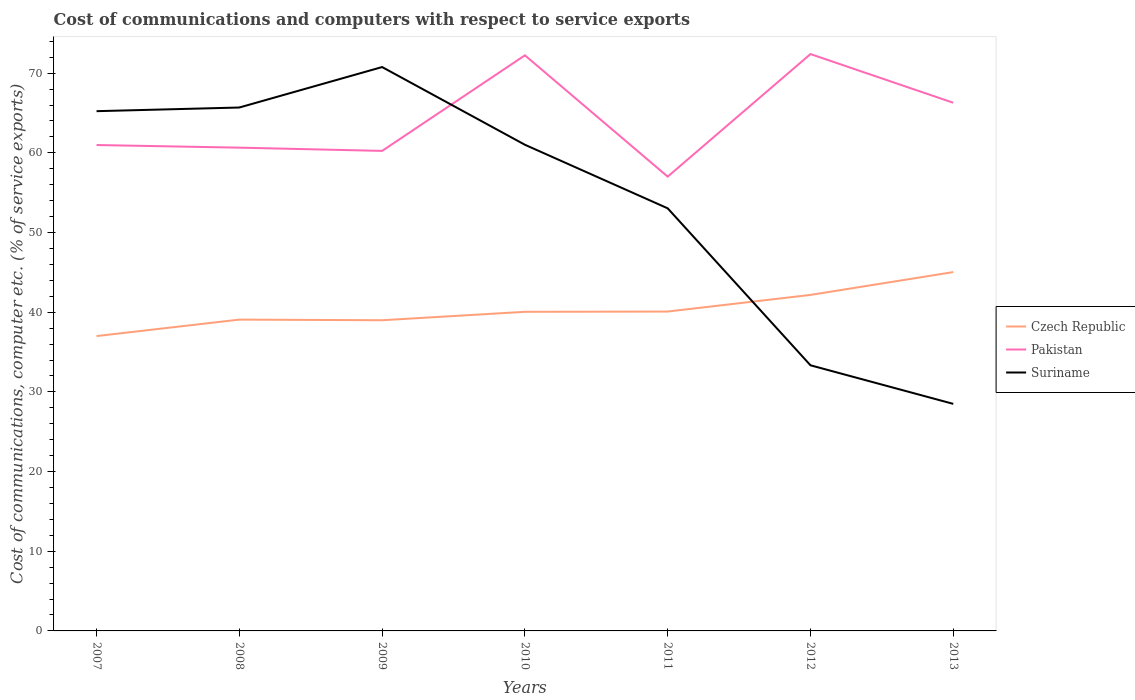Is the number of lines equal to the number of legend labels?
Keep it short and to the point. Yes. Across all years, what is the maximum cost of communications and computers in Czech Republic?
Keep it short and to the point. 37.01. In which year was the cost of communications and computers in Suriname maximum?
Ensure brevity in your answer.  2013. What is the total cost of communications and computers in Suriname in the graph?
Offer a very short reply. 24.54. What is the difference between the highest and the second highest cost of communications and computers in Pakistan?
Offer a very short reply. 15.38. What is the difference between the highest and the lowest cost of communications and computers in Czech Republic?
Ensure brevity in your answer.  2. How many lines are there?
Provide a succinct answer. 3. How many years are there in the graph?
Offer a terse response. 7. What is the difference between two consecutive major ticks on the Y-axis?
Make the answer very short. 10. Are the values on the major ticks of Y-axis written in scientific E-notation?
Offer a terse response. No. How are the legend labels stacked?
Your answer should be very brief. Vertical. What is the title of the graph?
Keep it short and to the point. Cost of communications and computers with respect to service exports. What is the label or title of the X-axis?
Your response must be concise. Years. What is the label or title of the Y-axis?
Ensure brevity in your answer.  Cost of communications, computer etc. (% of service exports). What is the Cost of communications, computer etc. (% of service exports) of Czech Republic in 2007?
Your answer should be compact. 37.01. What is the Cost of communications, computer etc. (% of service exports) in Pakistan in 2007?
Give a very brief answer. 60.98. What is the Cost of communications, computer etc. (% of service exports) in Suriname in 2007?
Provide a short and direct response. 65.23. What is the Cost of communications, computer etc. (% of service exports) of Czech Republic in 2008?
Make the answer very short. 39.07. What is the Cost of communications, computer etc. (% of service exports) of Pakistan in 2008?
Your answer should be very brief. 60.65. What is the Cost of communications, computer etc. (% of service exports) of Suriname in 2008?
Offer a very short reply. 65.69. What is the Cost of communications, computer etc. (% of service exports) in Czech Republic in 2009?
Provide a succinct answer. 38.99. What is the Cost of communications, computer etc. (% of service exports) in Pakistan in 2009?
Offer a very short reply. 60.25. What is the Cost of communications, computer etc. (% of service exports) in Suriname in 2009?
Ensure brevity in your answer.  70.77. What is the Cost of communications, computer etc. (% of service exports) of Czech Republic in 2010?
Keep it short and to the point. 40.05. What is the Cost of communications, computer etc. (% of service exports) of Pakistan in 2010?
Provide a short and direct response. 72.24. What is the Cost of communications, computer etc. (% of service exports) of Suriname in 2010?
Offer a very short reply. 61.02. What is the Cost of communications, computer etc. (% of service exports) in Czech Republic in 2011?
Ensure brevity in your answer.  40.09. What is the Cost of communications, computer etc. (% of service exports) of Pakistan in 2011?
Ensure brevity in your answer.  57.02. What is the Cost of communications, computer etc. (% of service exports) of Suriname in 2011?
Give a very brief answer. 53.04. What is the Cost of communications, computer etc. (% of service exports) in Czech Republic in 2012?
Provide a short and direct response. 42.17. What is the Cost of communications, computer etc. (% of service exports) in Pakistan in 2012?
Give a very brief answer. 72.4. What is the Cost of communications, computer etc. (% of service exports) in Suriname in 2012?
Make the answer very short. 33.34. What is the Cost of communications, computer etc. (% of service exports) of Czech Republic in 2013?
Provide a succinct answer. 45.04. What is the Cost of communications, computer etc. (% of service exports) of Pakistan in 2013?
Make the answer very short. 66.29. What is the Cost of communications, computer etc. (% of service exports) of Suriname in 2013?
Your answer should be very brief. 28.5. Across all years, what is the maximum Cost of communications, computer etc. (% of service exports) of Czech Republic?
Ensure brevity in your answer.  45.04. Across all years, what is the maximum Cost of communications, computer etc. (% of service exports) in Pakistan?
Offer a terse response. 72.4. Across all years, what is the maximum Cost of communications, computer etc. (% of service exports) in Suriname?
Ensure brevity in your answer.  70.77. Across all years, what is the minimum Cost of communications, computer etc. (% of service exports) in Czech Republic?
Your response must be concise. 37.01. Across all years, what is the minimum Cost of communications, computer etc. (% of service exports) in Pakistan?
Keep it short and to the point. 57.02. Across all years, what is the minimum Cost of communications, computer etc. (% of service exports) of Suriname?
Your answer should be compact. 28.5. What is the total Cost of communications, computer etc. (% of service exports) in Czech Republic in the graph?
Your answer should be compact. 282.42. What is the total Cost of communications, computer etc. (% of service exports) in Pakistan in the graph?
Give a very brief answer. 449.84. What is the total Cost of communications, computer etc. (% of service exports) of Suriname in the graph?
Your answer should be compact. 377.59. What is the difference between the Cost of communications, computer etc. (% of service exports) of Czech Republic in 2007 and that in 2008?
Your response must be concise. -2.07. What is the difference between the Cost of communications, computer etc. (% of service exports) in Pakistan in 2007 and that in 2008?
Keep it short and to the point. 0.33. What is the difference between the Cost of communications, computer etc. (% of service exports) in Suriname in 2007 and that in 2008?
Provide a short and direct response. -0.46. What is the difference between the Cost of communications, computer etc. (% of service exports) of Czech Republic in 2007 and that in 2009?
Provide a succinct answer. -1.99. What is the difference between the Cost of communications, computer etc. (% of service exports) of Pakistan in 2007 and that in 2009?
Keep it short and to the point. 0.74. What is the difference between the Cost of communications, computer etc. (% of service exports) of Suriname in 2007 and that in 2009?
Provide a short and direct response. -5.54. What is the difference between the Cost of communications, computer etc. (% of service exports) in Czech Republic in 2007 and that in 2010?
Ensure brevity in your answer.  -3.04. What is the difference between the Cost of communications, computer etc. (% of service exports) of Pakistan in 2007 and that in 2010?
Give a very brief answer. -11.26. What is the difference between the Cost of communications, computer etc. (% of service exports) of Suriname in 2007 and that in 2010?
Your answer should be compact. 4.21. What is the difference between the Cost of communications, computer etc. (% of service exports) in Czech Republic in 2007 and that in 2011?
Give a very brief answer. -3.08. What is the difference between the Cost of communications, computer etc. (% of service exports) of Pakistan in 2007 and that in 2011?
Make the answer very short. 3.96. What is the difference between the Cost of communications, computer etc. (% of service exports) of Suriname in 2007 and that in 2011?
Offer a terse response. 12.19. What is the difference between the Cost of communications, computer etc. (% of service exports) in Czech Republic in 2007 and that in 2012?
Your response must be concise. -5.17. What is the difference between the Cost of communications, computer etc. (% of service exports) in Pakistan in 2007 and that in 2012?
Your answer should be very brief. -11.42. What is the difference between the Cost of communications, computer etc. (% of service exports) of Suriname in 2007 and that in 2012?
Offer a terse response. 31.89. What is the difference between the Cost of communications, computer etc. (% of service exports) in Czech Republic in 2007 and that in 2013?
Offer a terse response. -8.03. What is the difference between the Cost of communications, computer etc. (% of service exports) in Pakistan in 2007 and that in 2013?
Give a very brief answer. -5.31. What is the difference between the Cost of communications, computer etc. (% of service exports) of Suriname in 2007 and that in 2013?
Offer a terse response. 36.74. What is the difference between the Cost of communications, computer etc. (% of service exports) in Czech Republic in 2008 and that in 2009?
Keep it short and to the point. 0.08. What is the difference between the Cost of communications, computer etc. (% of service exports) of Pakistan in 2008 and that in 2009?
Offer a very short reply. 0.41. What is the difference between the Cost of communications, computer etc. (% of service exports) of Suriname in 2008 and that in 2009?
Give a very brief answer. -5.08. What is the difference between the Cost of communications, computer etc. (% of service exports) of Czech Republic in 2008 and that in 2010?
Offer a terse response. -0.98. What is the difference between the Cost of communications, computer etc. (% of service exports) of Pakistan in 2008 and that in 2010?
Your answer should be compact. -11.59. What is the difference between the Cost of communications, computer etc. (% of service exports) of Suriname in 2008 and that in 2010?
Give a very brief answer. 4.67. What is the difference between the Cost of communications, computer etc. (% of service exports) in Czech Republic in 2008 and that in 2011?
Your answer should be very brief. -1.01. What is the difference between the Cost of communications, computer etc. (% of service exports) in Pakistan in 2008 and that in 2011?
Your answer should be compact. 3.64. What is the difference between the Cost of communications, computer etc. (% of service exports) in Suriname in 2008 and that in 2011?
Give a very brief answer. 12.65. What is the difference between the Cost of communications, computer etc. (% of service exports) of Czech Republic in 2008 and that in 2012?
Make the answer very short. -3.1. What is the difference between the Cost of communications, computer etc. (% of service exports) of Pakistan in 2008 and that in 2012?
Provide a succinct answer. -11.75. What is the difference between the Cost of communications, computer etc. (% of service exports) of Suriname in 2008 and that in 2012?
Offer a terse response. 32.36. What is the difference between the Cost of communications, computer etc. (% of service exports) in Czech Republic in 2008 and that in 2013?
Your response must be concise. -5.96. What is the difference between the Cost of communications, computer etc. (% of service exports) of Pakistan in 2008 and that in 2013?
Give a very brief answer. -5.63. What is the difference between the Cost of communications, computer etc. (% of service exports) of Suriname in 2008 and that in 2013?
Your response must be concise. 37.2. What is the difference between the Cost of communications, computer etc. (% of service exports) in Czech Republic in 2009 and that in 2010?
Offer a terse response. -1.06. What is the difference between the Cost of communications, computer etc. (% of service exports) in Pakistan in 2009 and that in 2010?
Offer a terse response. -12. What is the difference between the Cost of communications, computer etc. (% of service exports) in Suriname in 2009 and that in 2010?
Make the answer very short. 9.75. What is the difference between the Cost of communications, computer etc. (% of service exports) in Czech Republic in 2009 and that in 2011?
Offer a very short reply. -1.09. What is the difference between the Cost of communications, computer etc. (% of service exports) of Pakistan in 2009 and that in 2011?
Your answer should be compact. 3.23. What is the difference between the Cost of communications, computer etc. (% of service exports) in Suriname in 2009 and that in 2011?
Your answer should be compact. 17.73. What is the difference between the Cost of communications, computer etc. (% of service exports) of Czech Republic in 2009 and that in 2012?
Offer a very short reply. -3.18. What is the difference between the Cost of communications, computer etc. (% of service exports) of Pakistan in 2009 and that in 2012?
Provide a succinct answer. -12.15. What is the difference between the Cost of communications, computer etc. (% of service exports) of Suriname in 2009 and that in 2012?
Provide a succinct answer. 37.43. What is the difference between the Cost of communications, computer etc. (% of service exports) of Czech Republic in 2009 and that in 2013?
Provide a short and direct response. -6.04. What is the difference between the Cost of communications, computer etc. (% of service exports) in Pakistan in 2009 and that in 2013?
Keep it short and to the point. -6.04. What is the difference between the Cost of communications, computer etc. (% of service exports) in Suriname in 2009 and that in 2013?
Make the answer very short. 42.27. What is the difference between the Cost of communications, computer etc. (% of service exports) in Czech Republic in 2010 and that in 2011?
Your answer should be very brief. -0.03. What is the difference between the Cost of communications, computer etc. (% of service exports) in Pakistan in 2010 and that in 2011?
Your response must be concise. 15.22. What is the difference between the Cost of communications, computer etc. (% of service exports) in Suriname in 2010 and that in 2011?
Provide a succinct answer. 7.98. What is the difference between the Cost of communications, computer etc. (% of service exports) of Czech Republic in 2010 and that in 2012?
Provide a succinct answer. -2.12. What is the difference between the Cost of communications, computer etc. (% of service exports) of Pakistan in 2010 and that in 2012?
Offer a terse response. -0.16. What is the difference between the Cost of communications, computer etc. (% of service exports) of Suriname in 2010 and that in 2012?
Keep it short and to the point. 27.68. What is the difference between the Cost of communications, computer etc. (% of service exports) of Czech Republic in 2010 and that in 2013?
Your answer should be very brief. -4.99. What is the difference between the Cost of communications, computer etc. (% of service exports) of Pakistan in 2010 and that in 2013?
Provide a succinct answer. 5.95. What is the difference between the Cost of communications, computer etc. (% of service exports) of Suriname in 2010 and that in 2013?
Your answer should be compact. 32.52. What is the difference between the Cost of communications, computer etc. (% of service exports) in Czech Republic in 2011 and that in 2012?
Give a very brief answer. -2.09. What is the difference between the Cost of communications, computer etc. (% of service exports) of Pakistan in 2011 and that in 2012?
Provide a succinct answer. -15.38. What is the difference between the Cost of communications, computer etc. (% of service exports) of Suriname in 2011 and that in 2012?
Keep it short and to the point. 19.7. What is the difference between the Cost of communications, computer etc. (% of service exports) in Czech Republic in 2011 and that in 2013?
Your answer should be compact. -4.95. What is the difference between the Cost of communications, computer etc. (% of service exports) of Pakistan in 2011 and that in 2013?
Ensure brevity in your answer.  -9.27. What is the difference between the Cost of communications, computer etc. (% of service exports) of Suriname in 2011 and that in 2013?
Your answer should be compact. 24.54. What is the difference between the Cost of communications, computer etc. (% of service exports) in Czech Republic in 2012 and that in 2013?
Provide a short and direct response. -2.87. What is the difference between the Cost of communications, computer etc. (% of service exports) in Pakistan in 2012 and that in 2013?
Your answer should be compact. 6.11. What is the difference between the Cost of communications, computer etc. (% of service exports) of Suriname in 2012 and that in 2013?
Offer a very short reply. 4.84. What is the difference between the Cost of communications, computer etc. (% of service exports) of Czech Republic in 2007 and the Cost of communications, computer etc. (% of service exports) of Pakistan in 2008?
Ensure brevity in your answer.  -23.65. What is the difference between the Cost of communications, computer etc. (% of service exports) in Czech Republic in 2007 and the Cost of communications, computer etc. (% of service exports) in Suriname in 2008?
Make the answer very short. -28.69. What is the difference between the Cost of communications, computer etc. (% of service exports) in Pakistan in 2007 and the Cost of communications, computer etc. (% of service exports) in Suriname in 2008?
Your answer should be compact. -4.71. What is the difference between the Cost of communications, computer etc. (% of service exports) of Czech Republic in 2007 and the Cost of communications, computer etc. (% of service exports) of Pakistan in 2009?
Give a very brief answer. -23.24. What is the difference between the Cost of communications, computer etc. (% of service exports) in Czech Republic in 2007 and the Cost of communications, computer etc. (% of service exports) in Suriname in 2009?
Keep it short and to the point. -33.76. What is the difference between the Cost of communications, computer etc. (% of service exports) in Pakistan in 2007 and the Cost of communications, computer etc. (% of service exports) in Suriname in 2009?
Provide a succinct answer. -9.79. What is the difference between the Cost of communications, computer etc. (% of service exports) in Czech Republic in 2007 and the Cost of communications, computer etc. (% of service exports) in Pakistan in 2010?
Your answer should be compact. -35.24. What is the difference between the Cost of communications, computer etc. (% of service exports) in Czech Republic in 2007 and the Cost of communications, computer etc. (% of service exports) in Suriname in 2010?
Your answer should be very brief. -24.01. What is the difference between the Cost of communications, computer etc. (% of service exports) of Pakistan in 2007 and the Cost of communications, computer etc. (% of service exports) of Suriname in 2010?
Keep it short and to the point. -0.04. What is the difference between the Cost of communications, computer etc. (% of service exports) in Czech Republic in 2007 and the Cost of communications, computer etc. (% of service exports) in Pakistan in 2011?
Provide a short and direct response. -20.01. What is the difference between the Cost of communications, computer etc. (% of service exports) of Czech Republic in 2007 and the Cost of communications, computer etc. (% of service exports) of Suriname in 2011?
Give a very brief answer. -16.03. What is the difference between the Cost of communications, computer etc. (% of service exports) in Pakistan in 2007 and the Cost of communications, computer etc. (% of service exports) in Suriname in 2011?
Your answer should be compact. 7.94. What is the difference between the Cost of communications, computer etc. (% of service exports) in Czech Republic in 2007 and the Cost of communications, computer etc. (% of service exports) in Pakistan in 2012?
Provide a short and direct response. -35.39. What is the difference between the Cost of communications, computer etc. (% of service exports) in Czech Republic in 2007 and the Cost of communications, computer etc. (% of service exports) in Suriname in 2012?
Offer a terse response. 3.67. What is the difference between the Cost of communications, computer etc. (% of service exports) in Pakistan in 2007 and the Cost of communications, computer etc. (% of service exports) in Suriname in 2012?
Provide a succinct answer. 27.64. What is the difference between the Cost of communications, computer etc. (% of service exports) of Czech Republic in 2007 and the Cost of communications, computer etc. (% of service exports) of Pakistan in 2013?
Provide a succinct answer. -29.28. What is the difference between the Cost of communications, computer etc. (% of service exports) in Czech Republic in 2007 and the Cost of communications, computer etc. (% of service exports) in Suriname in 2013?
Offer a terse response. 8.51. What is the difference between the Cost of communications, computer etc. (% of service exports) in Pakistan in 2007 and the Cost of communications, computer etc. (% of service exports) in Suriname in 2013?
Provide a succinct answer. 32.49. What is the difference between the Cost of communications, computer etc. (% of service exports) of Czech Republic in 2008 and the Cost of communications, computer etc. (% of service exports) of Pakistan in 2009?
Make the answer very short. -21.17. What is the difference between the Cost of communications, computer etc. (% of service exports) in Czech Republic in 2008 and the Cost of communications, computer etc. (% of service exports) in Suriname in 2009?
Offer a very short reply. -31.7. What is the difference between the Cost of communications, computer etc. (% of service exports) in Pakistan in 2008 and the Cost of communications, computer etc. (% of service exports) in Suriname in 2009?
Provide a short and direct response. -10.12. What is the difference between the Cost of communications, computer etc. (% of service exports) of Czech Republic in 2008 and the Cost of communications, computer etc. (% of service exports) of Pakistan in 2010?
Give a very brief answer. -33.17. What is the difference between the Cost of communications, computer etc. (% of service exports) in Czech Republic in 2008 and the Cost of communications, computer etc. (% of service exports) in Suriname in 2010?
Your response must be concise. -21.95. What is the difference between the Cost of communications, computer etc. (% of service exports) of Pakistan in 2008 and the Cost of communications, computer etc. (% of service exports) of Suriname in 2010?
Your answer should be compact. -0.36. What is the difference between the Cost of communications, computer etc. (% of service exports) in Czech Republic in 2008 and the Cost of communications, computer etc. (% of service exports) in Pakistan in 2011?
Keep it short and to the point. -17.95. What is the difference between the Cost of communications, computer etc. (% of service exports) of Czech Republic in 2008 and the Cost of communications, computer etc. (% of service exports) of Suriname in 2011?
Offer a terse response. -13.97. What is the difference between the Cost of communications, computer etc. (% of service exports) in Pakistan in 2008 and the Cost of communications, computer etc. (% of service exports) in Suriname in 2011?
Ensure brevity in your answer.  7.61. What is the difference between the Cost of communications, computer etc. (% of service exports) of Czech Republic in 2008 and the Cost of communications, computer etc. (% of service exports) of Pakistan in 2012?
Offer a terse response. -33.33. What is the difference between the Cost of communications, computer etc. (% of service exports) in Czech Republic in 2008 and the Cost of communications, computer etc. (% of service exports) in Suriname in 2012?
Your response must be concise. 5.74. What is the difference between the Cost of communications, computer etc. (% of service exports) in Pakistan in 2008 and the Cost of communications, computer etc. (% of service exports) in Suriname in 2012?
Your answer should be compact. 27.32. What is the difference between the Cost of communications, computer etc. (% of service exports) in Czech Republic in 2008 and the Cost of communications, computer etc. (% of service exports) in Pakistan in 2013?
Make the answer very short. -27.22. What is the difference between the Cost of communications, computer etc. (% of service exports) of Czech Republic in 2008 and the Cost of communications, computer etc. (% of service exports) of Suriname in 2013?
Offer a terse response. 10.58. What is the difference between the Cost of communications, computer etc. (% of service exports) of Pakistan in 2008 and the Cost of communications, computer etc. (% of service exports) of Suriname in 2013?
Provide a short and direct response. 32.16. What is the difference between the Cost of communications, computer etc. (% of service exports) in Czech Republic in 2009 and the Cost of communications, computer etc. (% of service exports) in Pakistan in 2010?
Make the answer very short. -33.25. What is the difference between the Cost of communications, computer etc. (% of service exports) in Czech Republic in 2009 and the Cost of communications, computer etc. (% of service exports) in Suriname in 2010?
Keep it short and to the point. -22.02. What is the difference between the Cost of communications, computer etc. (% of service exports) in Pakistan in 2009 and the Cost of communications, computer etc. (% of service exports) in Suriname in 2010?
Provide a short and direct response. -0.77. What is the difference between the Cost of communications, computer etc. (% of service exports) of Czech Republic in 2009 and the Cost of communications, computer etc. (% of service exports) of Pakistan in 2011?
Provide a succinct answer. -18.02. What is the difference between the Cost of communications, computer etc. (% of service exports) in Czech Republic in 2009 and the Cost of communications, computer etc. (% of service exports) in Suriname in 2011?
Your answer should be compact. -14.05. What is the difference between the Cost of communications, computer etc. (% of service exports) of Pakistan in 2009 and the Cost of communications, computer etc. (% of service exports) of Suriname in 2011?
Give a very brief answer. 7.21. What is the difference between the Cost of communications, computer etc. (% of service exports) of Czech Republic in 2009 and the Cost of communications, computer etc. (% of service exports) of Pakistan in 2012?
Your response must be concise. -33.41. What is the difference between the Cost of communications, computer etc. (% of service exports) in Czech Republic in 2009 and the Cost of communications, computer etc. (% of service exports) in Suriname in 2012?
Your response must be concise. 5.66. What is the difference between the Cost of communications, computer etc. (% of service exports) in Pakistan in 2009 and the Cost of communications, computer etc. (% of service exports) in Suriname in 2012?
Provide a succinct answer. 26.91. What is the difference between the Cost of communications, computer etc. (% of service exports) of Czech Republic in 2009 and the Cost of communications, computer etc. (% of service exports) of Pakistan in 2013?
Provide a short and direct response. -27.29. What is the difference between the Cost of communications, computer etc. (% of service exports) of Czech Republic in 2009 and the Cost of communications, computer etc. (% of service exports) of Suriname in 2013?
Your answer should be compact. 10.5. What is the difference between the Cost of communications, computer etc. (% of service exports) in Pakistan in 2009 and the Cost of communications, computer etc. (% of service exports) in Suriname in 2013?
Your response must be concise. 31.75. What is the difference between the Cost of communications, computer etc. (% of service exports) in Czech Republic in 2010 and the Cost of communications, computer etc. (% of service exports) in Pakistan in 2011?
Provide a succinct answer. -16.97. What is the difference between the Cost of communications, computer etc. (% of service exports) of Czech Republic in 2010 and the Cost of communications, computer etc. (% of service exports) of Suriname in 2011?
Offer a terse response. -12.99. What is the difference between the Cost of communications, computer etc. (% of service exports) of Pakistan in 2010 and the Cost of communications, computer etc. (% of service exports) of Suriname in 2011?
Make the answer very short. 19.2. What is the difference between the Cost of communications, computer etc. (% of service exports) in Czech Republic in 2010 and the Cost of communications, computer etc. (% of service exports) in Pakistan in 2012?
Your answer should be compact. -32.35. What is the difference between the Cost of communications, computer etc. (% of service exports) of Czech Republic in 2010 and the Cost of communications, computer etc. (% of service exports) of Suriname in 2012?
Offer a terse response. 6.71. What is the difference between the Cost of communications, computer etc. (% of service exports) in Pakistan in 2010 and the Cost of communications, computer etc. (% of service exports) in Suriname in 2012?
Give a very brief answer. 38.91. What is the difference between the Cost of communications, computer etc. (% of service exports) in Czech Republic in 2010 and the Cost of communications, computer etc. (% of service exports) in Pakistan in 2013?
Give a very brief answer. -26.24. What is the difference between the Cost of communications, computer etc. (% of service exports) in Czech Republic in 2010 and the Cost of communications, computer etc. (% of service exports) in Suriname in 2013?
Offer a very short reply. 11.55. What is the difference between the Cost of communications, computer etc. (% of service exports) in Pakistan in 2010 and the Cost of communications, computer etc. (% of service exports) in Suriname in 2013?
Provide a short and direct response. 43.75. What is the difference between the Cost of communications, computer etc. (% of service exports) in Czech Republic in 2011 and the Cost of communications, computer etc. (% of service exports) in Pakistan in 2012?
Make the answer very short. -32.32. What is the difference between the Cost of communications, computer etc. (% of service exports) in Czech Republic in 2011 and the Cost of communications, computer etc. (% of service exports) in Suriname in 2012?
Your answer should be very brief. 6.75. What is the difference between the Cost of communications, computer etc. (% of service exports) of Pakistan in 2011 and the Cost of communications, computer etc. (% of service exports) of Suriname in 2012?
Ensure brevity in your answer.  23.68. What is the difference between the Cost of communications, computer etc. (% of service exports) in Czech Republic in 2011 and the Cost of communications, computer etc. (% of service exports) in Pakistan in 2013?
Provide a succinct answer. -26.2. What is the difference between the Cost of communications, computer etc. (% of service exports) in Czech Republic in 2011 and the Cost of communications, computer etc. (% of service exports) in Suriname in 2013?
Provide a succinct answer. 11.59. What is the difference between the Cost of communications, computer etc. (% of service exports) of Pakistan in 2011 and the Cost of communications, computer etc. (% of service exports) of Suriname in 2013?
Your answer should be compact. 28.52. What is the difference between the Cost of communications, computer etc. (% of service exports) of Czech Republic in 2012 and the Cost of communications, computer etc. (% of service exports) of Pakistan in 2013?
Keep it short and to the point. -24.12. What is the difference between the Cost of communications, computer etc. (% of service exports) in Czech Republic in 2012 and the Cost of communications, computer etc. (% of service exports) in Suriname in 2013?
Offer a very short reply. 13.67. What is the difference between the Cost of communications, computer etc. (% of service exports) in Pakistan in 2012 and the Cost of communications, computer etc. (% of service exports) in Suriname in 2013?
Give a very brief answer. 43.9. What is the average Cost of communications, computer etc. (% of service exports) of Czech Republic per year?
Keep it short and to the point. 40.35. What is the average Cost of communications, computer etc. (% of service exports) in Pakistan per year?
Make the answer very short. 64.26. What is the average Cost of communications, computer etc. (% of service exports) in Suriname per year?
Provide a succinct answer. 53.94. In the year 2007, what is the difference between the Cost of communications, computer etc. (% of service exports) in Czech Republic and Cost of communications, computer etc. (% of service exports) in Pakistan?
Your answer should be very brief. -23.98. In the year 2007, what is the difference between the Cost of communications, computer etc. (% of service exports) of Czech Republic and Cost of communications, computer etc. (% of service exports) of Suriname?
Offer a terse response. -28.23. In the year 2007, what is the difference between the Cost of communications, computer etc. (% of service exports) of Pakistan and Cost of communications, computer etc. (% of service exports) of Suriname?
Your answer should be very brief. -4.25. In the year 2008, what is the difference between the Cost of communications, computer etc. (% of service exports) of Czech Republic and Cost of communications, computer etc. (% of service exports) of Pakistan?
Offer a very short reply. -21.58. In the year 2008, what is the difference between the Cost of communications, computer etc. (% of service exports) in Czech Republic and Cost of communications, computer etc. (% of service exports) in Suriname?
Provide a short and direct response. -26.62. In the year 2008, what is the difference between the Cost of communications, computer etc. (% of service exports) in Pakistan and Cost of communications, computer etc. (% of service exports) in Suriname?
Provide a short and direct response. -5.04. In the year 2009, what is the difference between the Cost of communications, computer etc. (% of service exports) of Czech Republic and Cost of communications, computer etc. (% of service exports) of Pakistan?
Ensure brevity in your answer.  -21.25. In the year 2009, what is the difference between the Cost of communications, computer etc. (% of service exports) of Czech Republic and Cost of communications, computer etc. (% of service exports) of Suriname?
Give a very brief answer. -31.78. In the year 2009, what is the difference between the Cost of communications, computer etc. (% of service exports) of Pakistan and Cost of communications, computer etc. (% of service exports) of Suriname?
Your answer should be very brief. -10.52. In the year 2010, what is the difference between the Cost of communications, computer etc. (% of service exports) in Czech Republic and Cost of communications, computer etc. (% of service exports) in Pakistan?
Give a very brief answer. -32.19. In the year 2010, what is the difference between the Cost of communications, computer etc. (% of service exports) in Czech Republic and Cost of communications, computer etc. (% of service exports) in Suriname?
Offer a very short reply. -20.97. In the year 2010, what is the difference between the Cost of communications, computer etc. (% of service exports) in Pakistan and Cost of communications, computer etc. (% of service exports) in Suriname?
Provide a succinct answer. 11.22. In the year 2011, what is the difference between the Cost of communications, computer etc. (% of service exports) of Czech Republic and Cost of communications, computer etc. (% of service exports) of Pakistan?
Your answer should be very brief. -16.93. In the year 2011, what is the difference between the Cost of communications, computer etc. (% of service exports) in Czech Republic and Cost of communications, computer etc. (% of service exports) in Suriname?
Your answer should be very brief. -12.96. In the year 2011, what is the difference between the Cost of communications, computer etc. (% of service exports) in Pakistan and Cost of communications, computer etc. (% of service exports) in Suriname?
Your answer should be compact. 3.98. In the year 2012, what is the difference between the Cost of communications, computer etc. (% of service exports) in Czech Republic and Cost of communications, computer etc. (% of service exports) in Pakistan?
Keep it short and to the point. -30.23. In the year 2012, what is the difference between the Cost of communications, computer etc. (% of service exports) of Czech Republic and Cost of communications, computer etc. (% of service exports) of Suriname?
Make the answer very short. 8.83. In the year 2012, what is the difference between the Cost of communications, computer etc. (% of service exports) of Pakistan and Cost of communications, computer etc. (% of service exports) of Suriname?
Offer a terse response. 39.06. In the year 2013, what is the difference between the Cost of communications, computer etc. (% of service exports) of Czech Republic and Cost of communications, computer etc. (% of service exports) of Pakistan?
Your answer should be very brief. -21.25. In the year 2013, what is the difference between the Cost of communications, computer etc. (% of service exports) of Czech Republic and Cost of communications, computer etc. (% of service exports) of Suriname?
Offer a terse response. 16.54. In the year 2013, what is the difference between the Cost of communications, computer etc. (% of service exports) in Pakistan and Cost of communications, computer etc. (% of service exports) in Suriname?
Your answer should be compact. 37.79. What is the ratio of the Cost of communications, computer etc. (% of service exports) in Czech Republic in 2007 to that in 2008?
Ensure brevity in your answer.  0.95. What is the ratio of the Cost of communications, computer etc. (% of service exports) in Pakistan in 2007 to that in 2008?
Offer a terse response. 1.01. What is the ratio of the Cost of communications, computer etc. (% of service exports) of Czech Republic in 2007 to that in 2009?
Your response must be concise. 0.95. What is the ratio of the Cost of communications, computer etc. (% of service exports) of Pakistan in 2007 to that in 2009?
Give a very brief answer. 1.01. What is the ratio of the Cost of communications, computer etc. (% of service exports) of Suriname in 2007 to that in 2009?
Offer a terse response. 0.92. What is the ratio of the Cost of communications, computer etc. (% of service exports) in Czech Republic in 2007 to that in 2010?
Keep it short and to the point. 0.92. What is the ratio of the Cost of communications, computer etc. (% of service exports) of Pakistan in 2007 to that in 2010?
Give a very brief answer. 0.84. What is the ratio of the Cost of communications, computer etc. (% of service exports) of Suriname in 2007 to that in 2010?
Ensure brevity in your answer.  1.07. What is the ratio of the Cost of communications, computer etc. (% of service exports) of Czech Republic in 2007 to that in 2011?
Offer a terse response. 0.92. What is the ratio of the Cost of communications, computer etc. (% of service exports) of Pakistan in 2007 to that in 2011?
Make the answer very short. 1.07. What is the ratio of the Cost of communications, computer etc. (% of service exports) of Suriname in 2007 to that in 2011?
Offer a very short reply. 1.23. What is the ratio of the Cost of communications, computer etc. (% of service exports) in Czech Republic in 2007 to that in 2012?
Provide a succinct answer. 0.88. What is the ratio of the Cost of communications, computer etc. (% of service exports) of Pakistan in 2007 to that in 2012?
Offer a very short reply. 0.84. What is the ratio of the Cost of communications, computer etc. (% of service exports) of Suriname in 2007 to that in 2012?
Provide a short and direct response. 1.96. What is the ratio of the Cost of communications, computer etc. (% of service exports) in Czech Republic in 2007 to that in 2013?
Make the answer very short. 0.82. What is the ratio of the Cost of communications, computer etc. (% of service exports) in Pakistan in 2007 to that in 2013?
Your answer should be very brief. 0.92. What is the ratio of the Cost of communications, computer etc. (% of service exports) of Suriname in 2007 to that in 2013?
Your answer should be compact. 2.29. What is the ratio of the Cost of communications, computer etc. (% of service exports) of Czech Republic in 2008 to that in 2009?
Your answer should be compact. 1. What is the ratio of the Cost of communications, computer etc. (% of service exports) in Pakistan in 2008 to that in 2009?
Offer a very short reply. 1.01. What is the ratio of the Cost of communications, computer etc. (% of service exports) of Suriname in 2008 to that in 2009?
Give a very brief answer. 0.93. What is the ratio of the Cost of communications, computer etc. (% of service exports) in Czech Republic in 2008 to that in 2010?
Provide a short and direct response. 0.98. What is the ratio of the Cost of communications, computer etc. (% of service exports) in Pakistan in 2008 to that in 2010?
Your response must be concise. 0.84. What is the ratio of the Cost of communications, computer etc. (% of service exports) in Suriname in 2008 to that in 2010?
Provide a succinct answer. 1.08. What is the ratio of the Cost of communications, computer etc. (% of service exports) in Czech Republic in 2008 to that in 2011?
Your response must be concise. 0.97. What is the ratio of the Cost of communications, computer etc. (% of service exports) of Pakistan in 2008 to that in 2011?
Your response must be concise. 1.06. What is the ratio of the Cost of communications, computer etc. (% of service exports) of Suriname in 2008 to that in 2011?
Ensure brevity in your answer.  1.24. What is the ratio of the Cost of communications, computer etc. (% of service exports) in Czech Republic in 2008 to that in 2012?
Provide a succinct answer. 0.93. What is the ratio of the Cost of communications, computer etc. (% of service exports) of Pakistan in 2008 to that in 2012?
Provide a succinct answer. 0.84. What is the ratio of the Cost of communications, computer etc. (% of service exports) in Suriname in 2008 to that in 2012?
Your answer should be compact. 1.97. What is the ratio of the Cost of communications, computer etc. (% of service exports) of Czech Republic in 2008 to that in 2013?
Ensure brevity in your answer.  0.87. What is the ratio of the Cost of communications, computer etc. (% of service exports) of Pakistan in 2008 to that in 2013?
Offer a very short reply. 0.92. What is the ratio of the Cost of communications, computer etc. (% of service exports) in Suriname in 2008 to that in 2013?
Offer a very short reply. 2.31. What is the ratio of the Cost of communications, computer etc. (% of service exports) in Czech Republic in 2009 to that in 2010?
Your response must be concise. 0.97. What is the ratio of the Cost of communications, computer etc. (% of service exports) of Pakistan in 2009 to that in 2010?
Your answer should be very brief. 0.83. What is the ratio of the Cost of communications, computer etc. (% of service exports) in Suriname in 2009 to that in 2010?
Your answer should be very brief. 1.16. What is the ratio of the Cost of communications, computer etc. (% of service exports) of Czech Republic in 2009 to that in 2011?
Offer a terse response. 0.97. What is the ratio of the Cost of communications, computer etc. (% of service exports) in Pakistan in 2009 to that in 2011?
Provide a short and direct response. 1.06. What is the ratio of the Cost of communications, computer etc. (% of service exports) in Suriname in 2009 to that in 2011?
Make the answer very short. 1.33. What is the ratio of the Cost of communications, computer etc. (% of service exports) in Czech Republic in 2009 to that in 2012?
Give a very brief answer. 0.92. What is the ratio of the Cost of communications, computer etc. (% of service exports) in Pakistan in 2009 to that in 2012?
Your response must be concise. 0.83. What is the ratio of the Cost of communications, computer etc. (% of service exports) of Suriname in 2009 to that in 2012?
Your answer should be compact. 2.12. What is the ratio of the Cost of communications, computer etc. (% of service exports) of Czech Republic in 2009 to that in 2013?
Give a very brief answer. 0.87. What is the ratio of the Cost of communications, computer etc. (% of service exports) in Pakistan in 2009 to that in 2013?
Offer a very short reply. 0.91. What is the ratio of the Cost of communications, computer etc. (% of service exports) in Suriname in 2009 to that in 2013?
Provide a short and direct response. 2.48. What is the ratio of the Cost of communications, computer etc. (% of service exports) of Pakistan in 2010 to that in 2011?
Your answer should be very brief. 1.27. What is the ratio of the Cost of communications, computer etc. (% of service exports) in Suriname in 2010 to that in 2011?
Your answer should be compact. 1.15. What is the ratio of the Cost of communications, computer etc. (% of service exports) in Czech Republic in 2010 to that in 2012?
Make the answer very short. 0.95. What is the ratio of the Cost of communications, computer etc. (% of service exports) in Pakistan in 2010 to that in 2012?
Offer a terse response. 1. What is the ratio of the Cost of communications, computer etc. (% of service exports) of Suriname in 2010 to that in 2012?
Provide a succinct answer. 1.83. What is the ratio of the Cost of communications, computer etc. (% of service exports) in Czech Republic in 2010 to that in 2013?
Provide a short and direct response. 0.89. What is the ratio of the Cost of communications, computer etc. (% of service exports) of Pakistan in 2010 to that in 2013?
Your answer should be compact. 1.09. What is the ratio of the Cost of communications, computer etc. (% of service exports) in Suriname in 2010 to that in 2013?
Ensure brevity in your answer.  2.14. What is the ratio of the Cost of communications, computer etc. (% of service exports) in Czech Republic in 2011 to that in 2012?
Ensure brevity in your answer.  0.95. What is the ratio of the Cost of communications, computer etc. (% of service exports) in Pakistan in 2011 to that in 2012?
Keep it short and to the point. 0.79. What is the ratio of the Cost of communications, computer etc. (% of service exports) of Suriname in 2011 to that in 2012?
Your response must be concise. 1.59. What is the ratio of the Cost of communications, computer etc. (% of service exports) in Czech Republic in 2011 to that in 2013?
Offer a very short reply. 0.89. What is the ratio of the Cost of communications, computer etc. (% of service exports) in Pakistan in 2011 to that in 2013?
Keep it short and to the point. 0.86. What is the ratio of the Cost of communications, computer etc. (% of service exports) of Suriname in 2011 to that in 2013?
Keep it short and to the point. 1.86. What is the ratio of the Cost of communications, computer etc. (% of service exports) in Czech Republic in 2012 to that in 2013?
Offer a very short reply. 0.94. What is the ratio of the Cost of communications, computer etc. (% of service exports) in Pakistan in 2012 to that in 2013?
Offer a terse response. 1.09. What is the ratio of the Cost of communications, computer etc. (% of service exports) in Suriname in 2012 to that in 2013?
Provide a succinct answer. 1.17. What is the difference between the highest and the second highest Cost of communications, computer etc. (% of service exports) in Czech Republic?
Provide a short and direct response. 2.87. What is the difference between the highest and the second highest Cost of communications, computer etc. (% of service exports) in Pakistan?
Provide a short and direct response. 0.16. What is the difference between the highest and the second highest Cost of communications, computer etc. (% of service exports) in Suriname?
Provide a short and direct response. 5.08. What is the difference between the highest and the lowest Cost of communications, computer etc. (% of service exports) of Czech Republic?
Your answer should be very brief. 8.03. What is the difference between the highest and the lowest Cost of communications, computer etc. (% of service exports) of Pakistan?
Provide a short and direct response. 15.38. What is the difference between the highest and the lowest Cost of communications, computer etc. (% of service exports) in Suriname?
Keep it short and to the point. 42.27. 